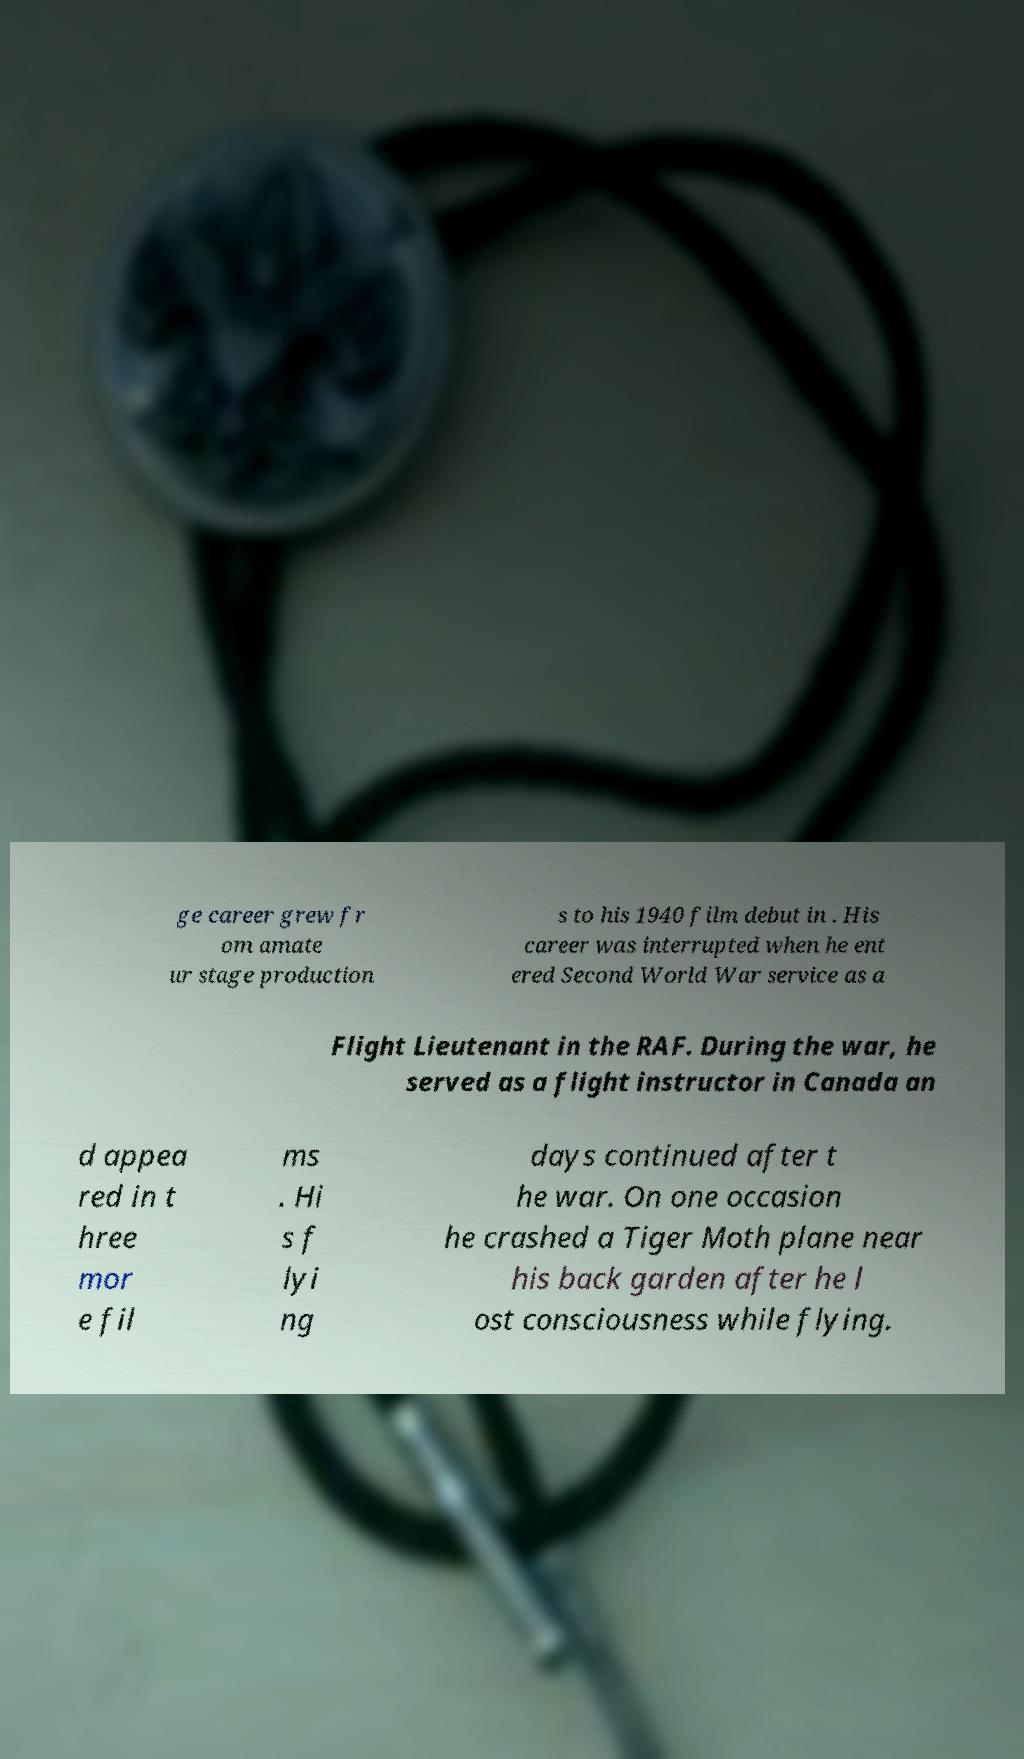Can you accurately transcribe the text from the provided image for me? ge career grew fr om amate ur stage production s to his 1940 film debut in . His career was interrupted when he ent ered Second World War service as a Flight Lieutenant in the RAF. During the war, he served as a flight instructor in Canada an d appea red in t hree mor e fil ms . Hi s f lyi ng days continued after t he war. On one occasion he crashed a Tiger Moth plane near his back garden after he l ost consciousness while flying. 